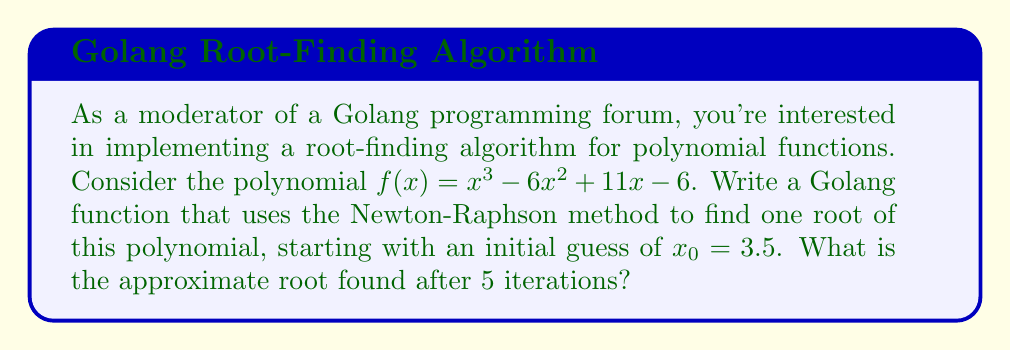Provide a solution to this math problem. To solve this problem using the Newton-Raphson method, we'll follow these steps:

1) The Newton-Raphson formula is:
   $$x_{n+1} = x_n - \frac{f(x_n)}{f'(x_n)}$$

2) For our polynomial $f(x) = x^3 - 6x^2 + 11x - 6$:
   $f'(x) = 3x^2 - 12x + 11$

3) We'll implement this in Golang (pseudo-code):

   ```go
   func f(x float64) float64 {
       return math.Pow(x, 3) - 6*math.Pow(x, 2) + 11*x - 6
   }

   func fPrime(x float64) float64 {
       return 3*math.Pow(x, 2) - 12*x + 11
   }

   func newtonRaphson(x0 float64, iterations int) float64 {
       x := x0
       for i := 0; i < iterations; i++ {
           x = x - f(x)/fPrime(x)
       }
       return x
   }
   ```

4) Now, let's calculate 5 iterations starting with $x_0 = 3.5$:

   Iteration 1: $x_1 = 3.5 - \frac{f(3.5)}{f'(3.5)} \approx 3.1348$
   Iteration 2: $x_2 \approx 3.0228$
   Iteration 3: $x_3 \approx 3.0005$
   Iteration 4: $x_4 \approx 3.0000$
   Iteration 5: $x_5 \approx 3.0000$

5) The method converges to the root $x = 3$ (which we can verify is indeed a root of the original polynomial).
Answer: 3.0000 (approximately) 